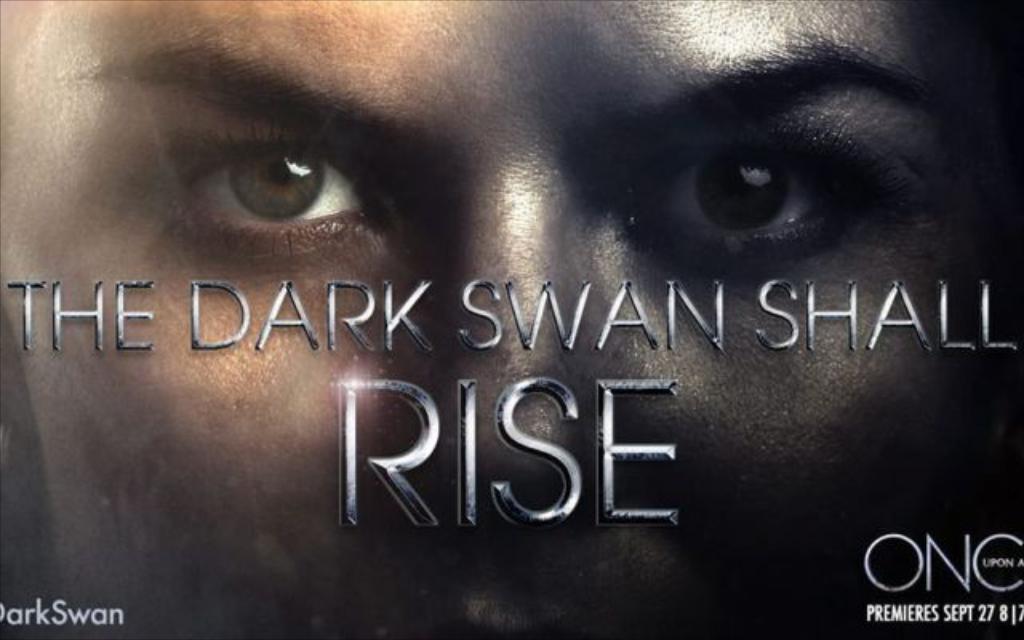Describe this image in one or two sentences. In this picture I can see a poster, on which I can see a person face and some text. 